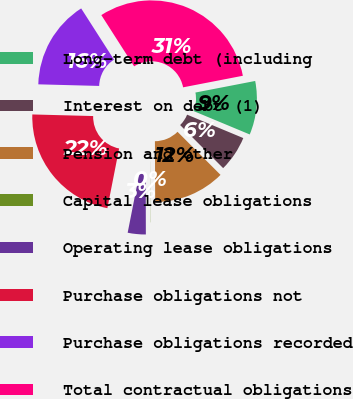<chart> <loc_0><loc_0><loc_500><loc_500><pie_chart><fcel>Long-term debt (including<fcel>Interest on debt (1)<fcel>Pension and other<fcel>Capital lease obligations<fcel>Operating lease obligations<fcel>Purchase obligations not<fcel>Purchase obligations recorded<fcel>Total contractual obligations<nl><fcel>9.33%<fcel>6.23%<fcel>12.42%<fcel>0.03%<fcel>3.13%<fcel>22.33%<fcel>15.52%<fcel>31.02%<nl></chart> 